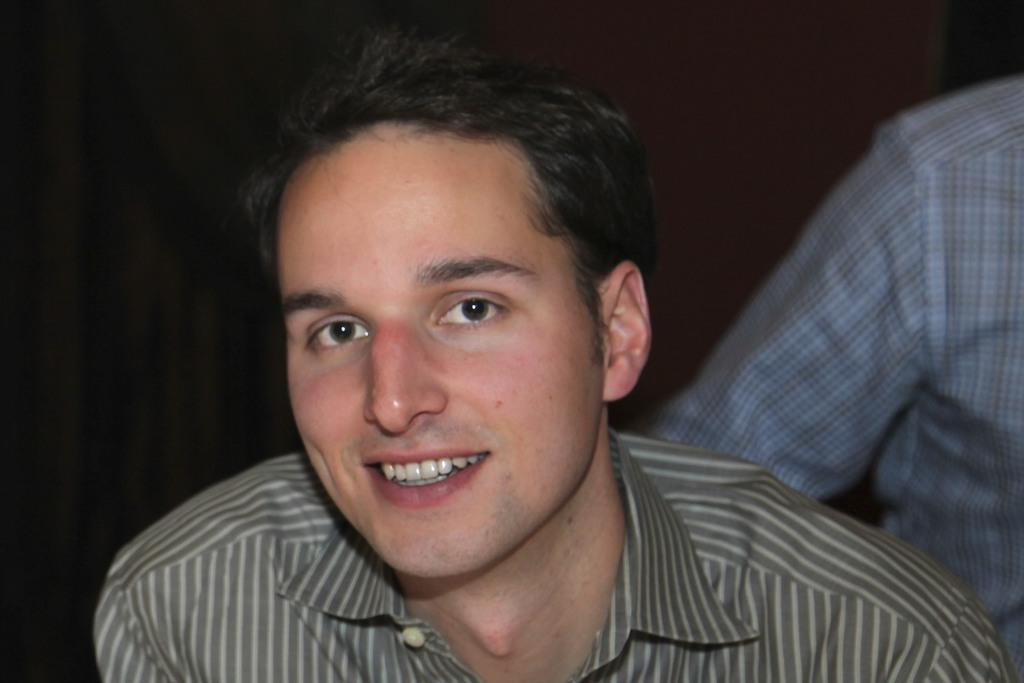What is the main subject of the image? There is a person in the image. What is the person in the image doing? The person is smiling. Can you describe the position of the second person in the image? There is another person behind the first person. What color is the background of the image? The background of the image is black. What type of fruit is the person holding in the image? There is no fruit visible in the image. Can you tell me how many guns are present in the image? There are no guns present in the image. 